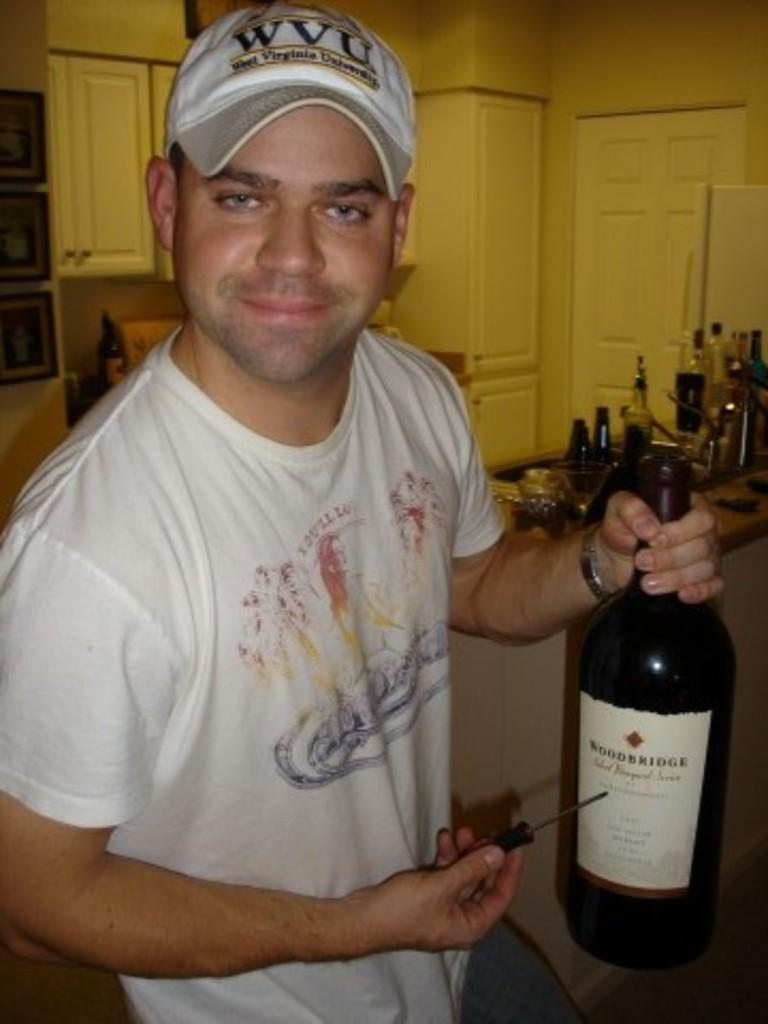What is the main subject of the picture? The main subject of the picture is a guy. What is the guy holding in one hand? The guy is holding a wine bottle in one hand. What is the guy holding in the other hand? The guy is holding a corkscrew opener in the other hand. Where was the picture taken? The picture was clicked inside a house. What type of protest can be seen happening in the background of the image? There is no protest visible in the image; it only shows a guy holding a wine bottle and a corkscrew opener inside a house. 